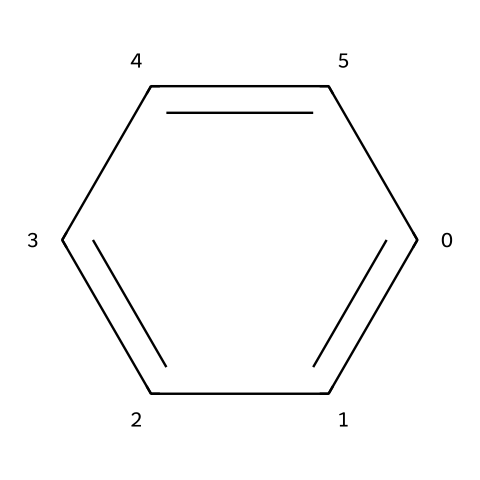What is the name of this chemical? The SMILES representation 'c1ccccc1' corresponds to a six-membered aromatic ring with alternating double bonds, which is known as benzene.
Answer: benzene How many carbon atoms are in the structure? The representation shows a total of six carbon atoms forming the ring structure, as inferred from the six 'c' in the SMILES.
Answer: six How many hydrogen atoms are attached to the benzene ring? Each carbon in benzene is bonded to one hydrogen atom, resulting in a total of six hydrogen atoms for six carbon atoms.
Answer: six What type of compound is benzene considered? Benzene is classified as an aromatic hydrocarbon due to its cyclic structure and alternating double bonds, fitting the criteria for aromaticity.
Answer: aromatic hydrocarbon What is a common property of benzene that makes it useful as a solvent? Benzene is a non-polar solvent that can effectively dissolve many organic compounds due to its ability to interact with non-polar substances.
Answer: non-polar Why can benzene be classified as a solvent in cleaning products? Benzene's ability to dissolve oils and greases, combined with its volatility, makes it effective in cleaning applications, allowing it to remove non-polar contaminants.
Answer: effective cleaner 